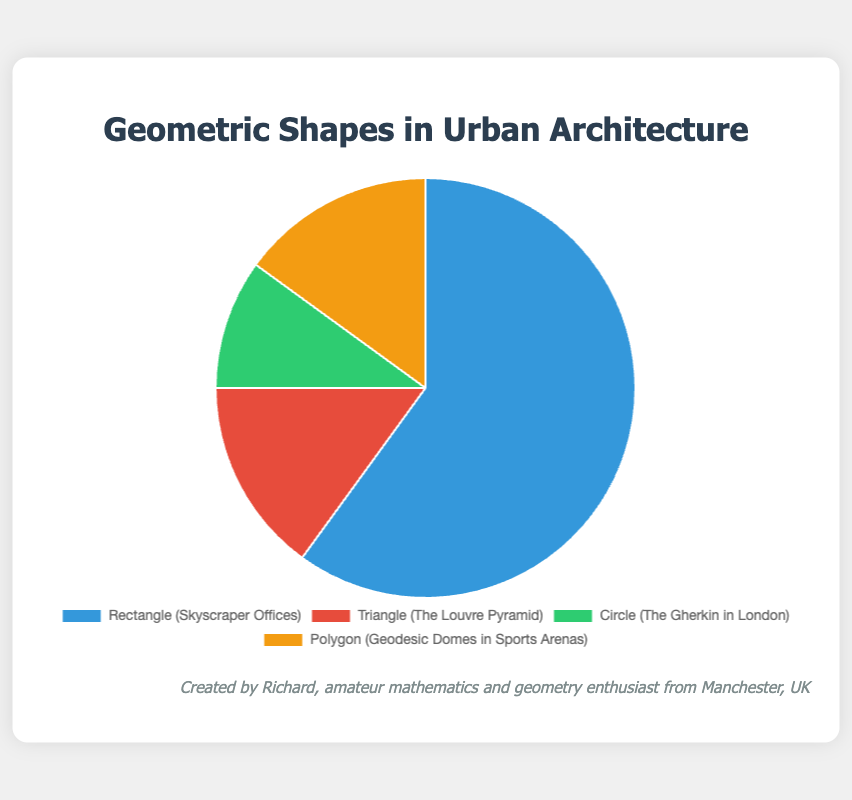What shape is used most frequently in urban architecture? The segment representing "Rectangle (Skyscraper Offices)" has the largest portion of the pie chart. Therefore, rectangles are used most frequently in urban architecture.
Answer: Rectangle Which shapes have equal usage percentages in urban architecture? The segments representing "Triangle (The Louvre Pyramid)" and "Polygon (Geodesic Domes in Sports Arenas)" both have 15% usage according to the pie chart.
Answer: Triangles and Polygons What is the combined percentage usage of Triangles and Circles in urban architecture? The usage of triangles is 15% and that of circles is 10%. Adding these percentages together, \(15\% + 10\%\ = 25\%\).
Answer: 25% Which shape category has the smallest portion in the pie chart, and what percentage does it occupy? The segment representing "Circle (The Gherkin in London)" has the smallest portion in the pie chart. It occupies 10% of the usage.
Answer: Circle, 10% What percentage usage do Polygons in urban architecture contribute compared to Rectangles? Polygons occupy a usage percentage of 15%, and rectangles occupy 60%. Comparing these, \(15\% / 60\% \times 100 = 25\%\).
Answer: 25% Which shape usage needs to increase by 5% to match the Rectangle usage? The current usage of rectangles is 60%. For triangles, which have 15%, to match it, they need an additional \(60\% - 15\% = 45\%\). To match polygons, which also have 15%, 45% more is needed. Circles, with 10%, require \(60\% - 10\% = 50\%\). Thus, no individual shape needs a 5% increase to match rectangles.
Answer: None Which shape has double the usage of Circles in the chart? The segment for circles shows 10% usage. The segments for both triangles and polygons each show 15% usage, which is more than double 10%, but not exactly double. No segment shows exactly double.
Answer: None What is the usage percentage if we sum up all shapes except Rectangles? Triangles have 15%, circles have 10%, and polygons have 15%. Summing these percentages equals \(15\% + 10\% + 15\% = 40\%\).
Answer: 40% Identify the shape associated with "The Gherkin in London" and its percentage. The label "Circle (The Gherkin in London)" represents the percentage usage of circles, which is indicated as 10%.
Answer: Circle, 10% What's the difference in percentage usage between the shape of "The Louvre Pyramid" and that of "Skyscraper Offices"? "The Louvre Pyramid" corresponds to triangles with 15% usage, and "Skyscraper Offices" corresponds to rectangles with 60% usage. The difference is \(60\% - 15\% = 45\%\).
Answer: 45% 